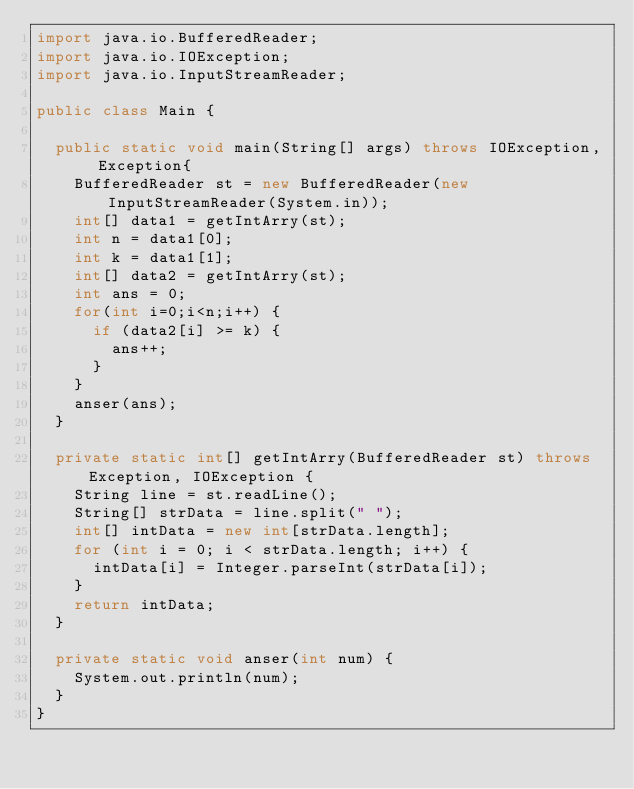Convert code to text. <code><loc_0><loc_0><loc_500><loc_500><_Java_>import java.io.BufferedReader;
import java.io.IOException;
import java.io.InputStreamReader;

public class Main {

	public static void main(String[] args) throws IOException, Exception{
		BufferedReader st = new BufferedReader(new InputStreamReader(System.in));
		int[] data1 = getIntArry(st);
		int n = data1[0];
		int k = data1[1];
		int[] data2 = getIntArry(st);
		int ans = 0;
		for(int i=0;i<n;i++) {
			if (data2[i] >= k) {
				ans++;
			}
		}
		anser(ans);
	}

	private static int[] getIntArry(BufferedReader st) throws Exception, IOException {
		String line = st.readLine();
		String[] strData = line.split(" ");
		int[] intData = new int[strData.length];
		for (int i = 0; i < strData.length; i++) {
			intData[i] = Integer.parseInt(strData[i]);
		}
		return intData;
	}

	private static void anser(int num) {
		System.out.println(num);
	}
}</code> 